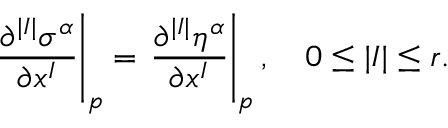<formula> <loc_0><loc_0><loc_500><loc_500>{ \frac { \partial ^ { | I | } \sigma ^ { \alpha } } { \partial x ^ { I } } } \right | _ { p } = { \frac { \partial ^ { | I | } \eta ^ { \alpha } } { \partial x ^ { I } } } \right | _ { p } , \quad 0 \leq | I | \leq r .</formula> 